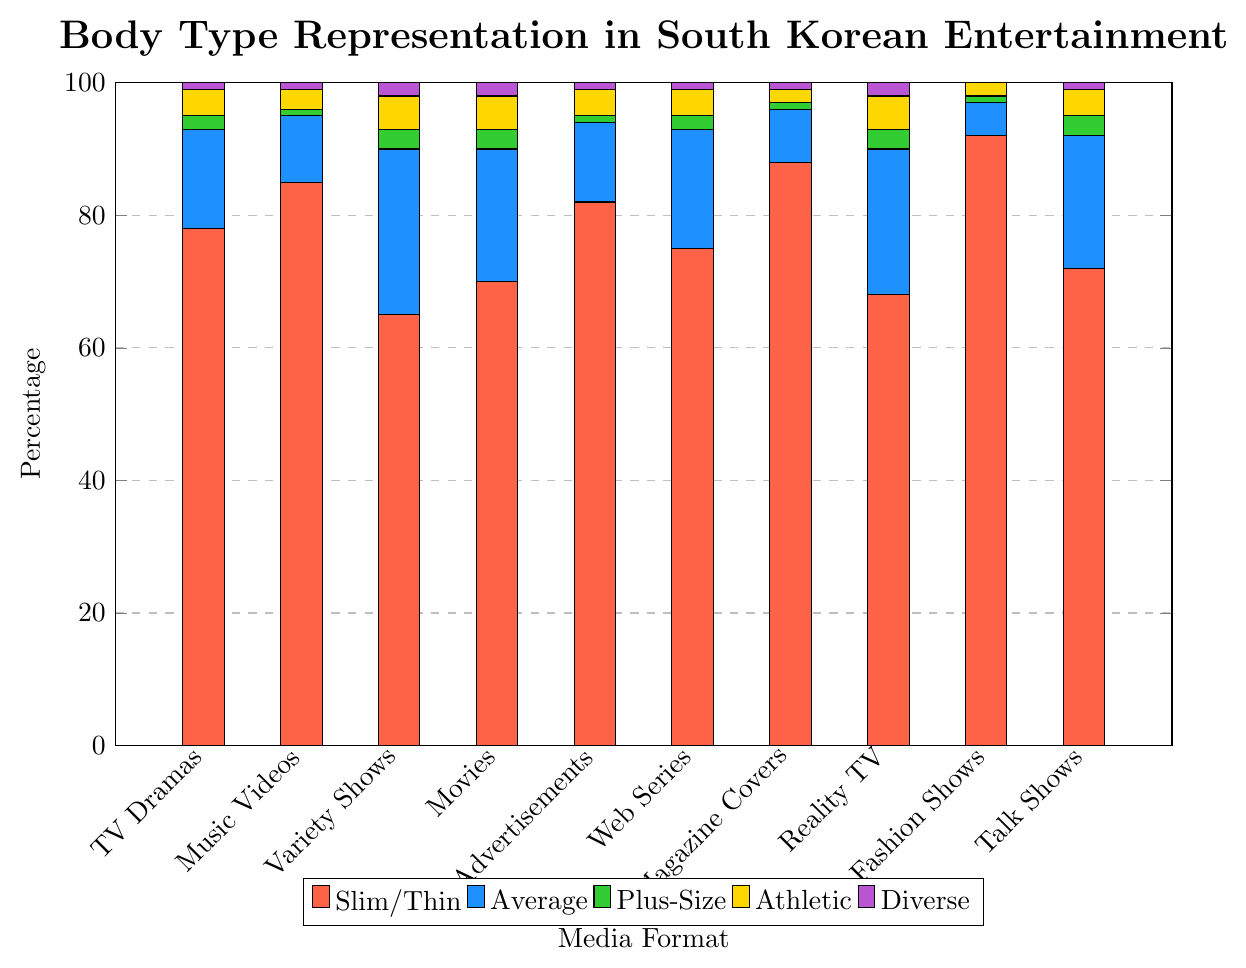What's the most represented body type in South Korean entertainment media according to the bar chart? The highest percentage across all media formats is represented by the Slim/Thin category. This can be determined by comparing the heights of the red bars, which are consistently the tallest.
Answer: Slim/Thin Which media format has the highest representation of the Athletic body type? By observing the heights of the yellow bars, the Variety Shows format has the highest percentage for the Athletic body type.
Answer: Variety Shows How many media formats have a plus-size representation of exactly 1%? Observing the green bars, we count the media formats where the height is 1. This occurs in Music Videos, Advertisements, Magazine Covers, and Fashion Shows—totaling 4 media formats.
Answer: 4 Compare the representation of Slim/Thin body types between Music Videos and Variety Shows. Which has a higher percentage and by how much? The red bar for Music Videos is taller, representing 85%, while for Variety Shows, it’s 65%. The difference is 85% - 65% = 20%.
Answer: Music Videos by 20% Which body type has the least representation on Magazine Covers? The shortest bar in the Magazine Covers data is purple, representing "Diverse".
Answer: Diverse In total, how much representation does the "Average" body type receive across all media formats? Sum the percentages represented by the blue bars: 15 + 10 + 25 + 20 + 12 + 18 + 8 + 22 + 5 + 20 = 155%.
Answer: 155% Which media format shows the most diverse representation of body types, considering uniformity in bar heights? Considering the bar heights across all body types, the Variety Shows format has the most balanced representation across Slim/Thin, Average, Plus-Size, Athletic, and Diverse.
Answer: Variety Shows What is the difference in the representation of Slim/Thin body types between Advertisements and Web Series? The red bar for Advertisements shows 82%, while for Web Series, it’s 75%. The difference is 82% - 75% = 7%.
Answer: 7% How does the representation of Plus-Size body types in Talk Shows compare to that in TV Dramas? The green bar for Plus-Size in Talk Shows is at 3%, while in TV Dramas it is at 2%, thus Talk Shows have a 1% higher representation.
Answer: Talk Shows by 1% Summarize the representation of body types in Reality TV by categorizing the presence of the Slim/Thin, Average, Plus-Size, Athletic, and Diverse body types as high, moderate, or low. Slim/Thin (high, 68%), Average (moderate, 22%), Plus-Size (low, 3%), Athletic (low, 5%), Diverse (low, 2%). High refers to above 50%, moderate between 10-50%, and low below 10%.
Answer: Categorized as high: Slim/Thin, moderate: Average, low: Plus-Size, Athletic, Diverse 